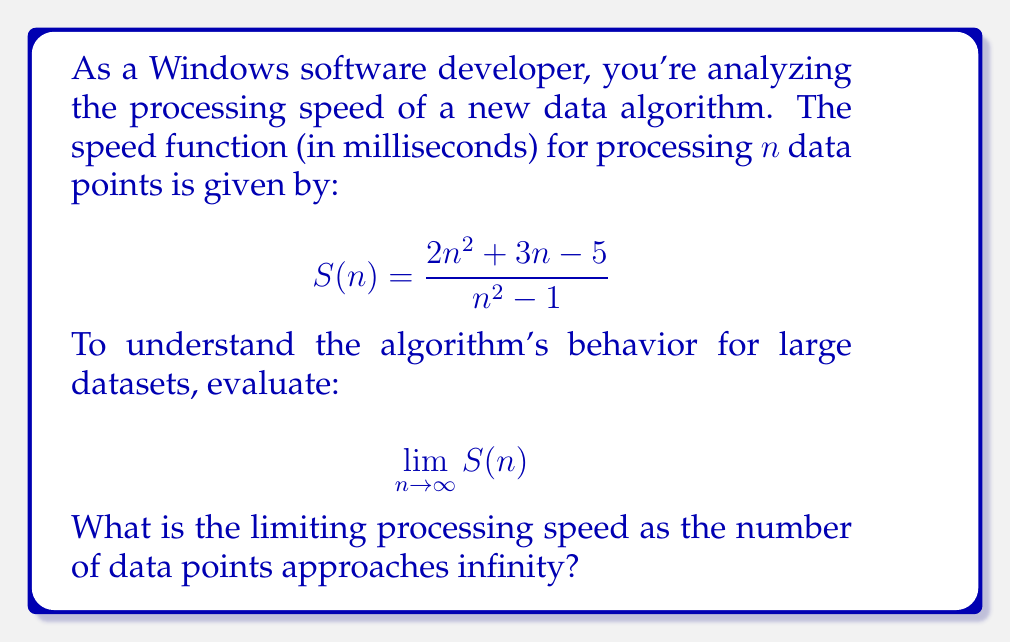Can you answer this question? Let's approach this step-by-step:

1) First, we need to analyze the behavior of the numerator and denominator separately as n approaches infinity.

2) For the numerator: $2n^2 + 3n - 5$
   The highest degree term is $2n^2$, which will dominate as n → ∞.

3) For the denominator: $n^2 - 1$
   The highest degree term is $n^2$, which will dominate as n → ∞.

4) We can divide both the numerator and denominator by $n^2$ (the highest power of n in the denominator):

   $$\lim_{n \to \infty} \frac{2n^2 + 3n - 5}{n^2 - 1} = \lim_{n \to \infty} \frac{2 + \frac{3}{n} - \frac{5}{n^2}}{1 - \frac{1}{n^2}}$$

5) As n → ∞, $\frac{3}{n}$, $\frac{5}{n^2}$, and $\frac{1}{n^2}$ all approach 0.

6) Therefore, the limit simplifies to:

   $$\lim_{n \to \infty} \frac{2 + 0 - 0}{1 - 0} = \frac{2}{1} = 2$$

This means that as the number of data points approaches infinity, the processing speed approaches 2 milliseconds per data point.
Answer: 2 milliseconds 